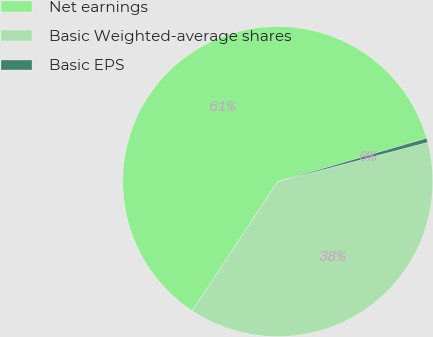<chart> <loc_0><loc_0><loc_500><loc_500><pie_chart><fcel>Net earnings<fcel>Basic Weighted-average shares<fcel>Basic EPS<nl><fcel>61.19%<fcel>38.37%<fcel>0.44%<nl></chart> 